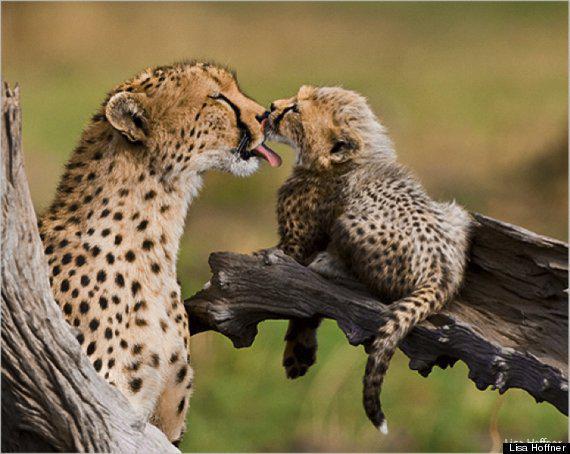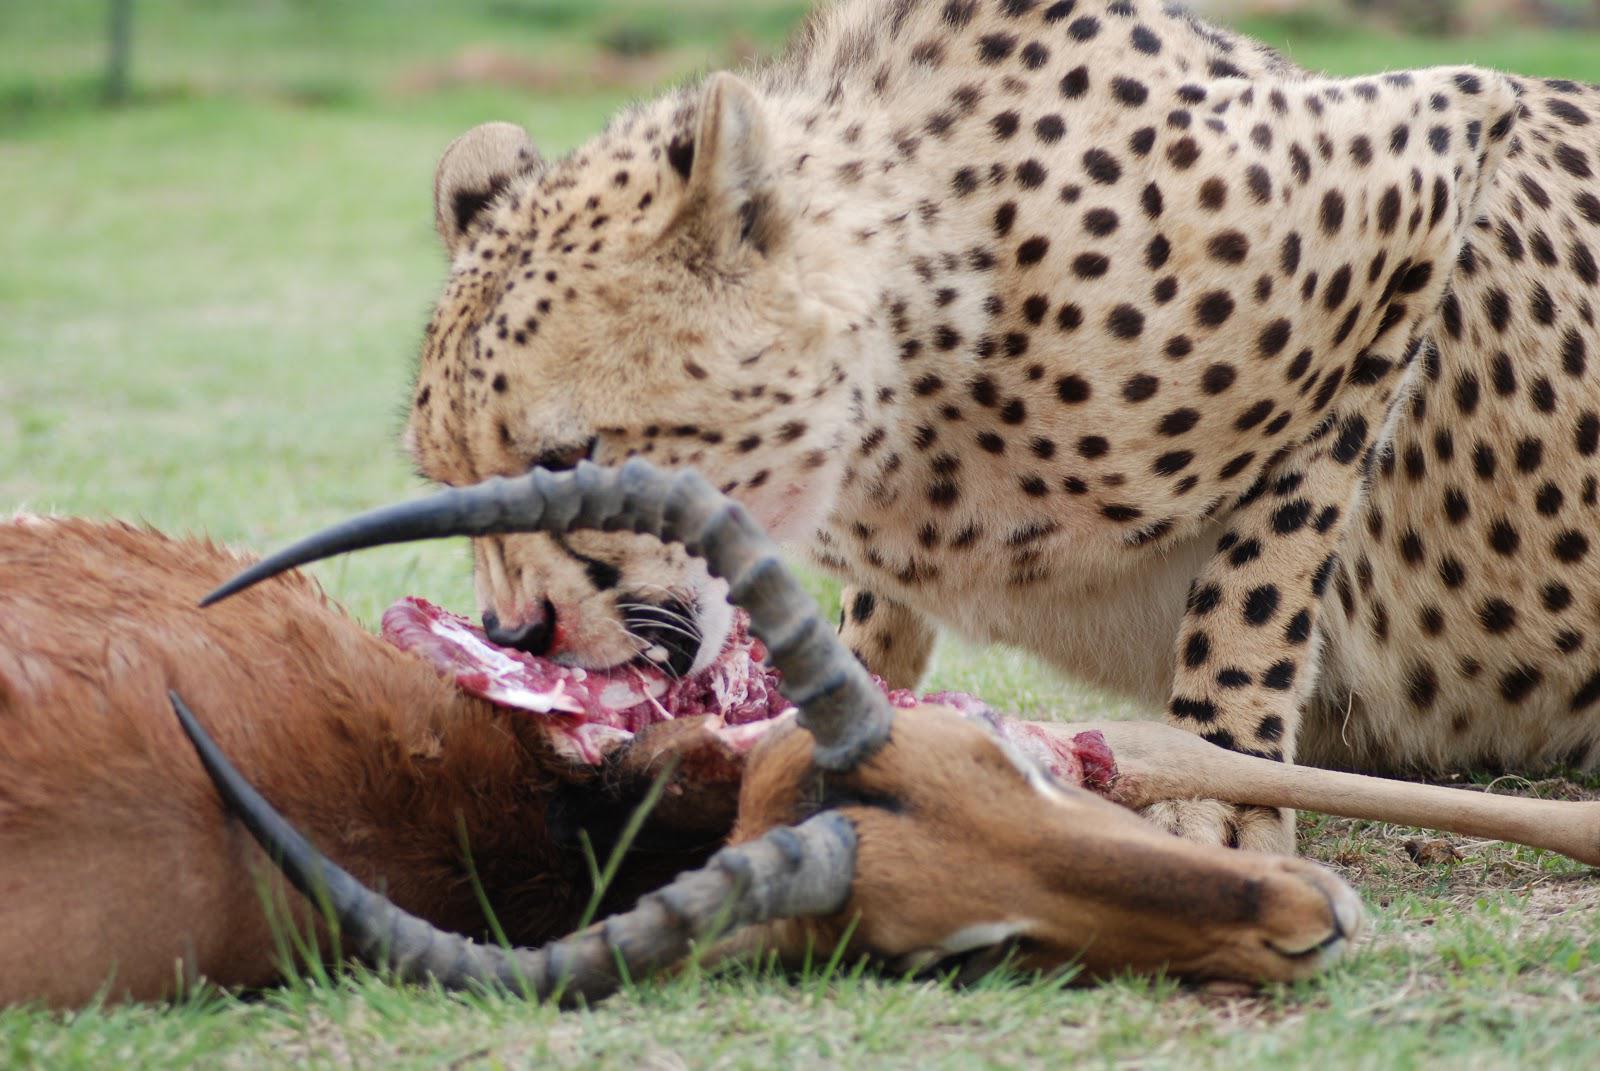The first image is the image on the left, the second image is the image on the right. Considering the images on both sides, is "In one of the images, there is at least one cheetah cub." valid? Answer yes or no. Yes. The first image is the image on the left, the second image is the image on the right. For the images displayed, is the sentence "One image includes an adult cheetah with its tongue out and no prey present, and the other image shows a gazelle preyed on by at least one cheetah." factually correct? Answer yes or no. Yes. 